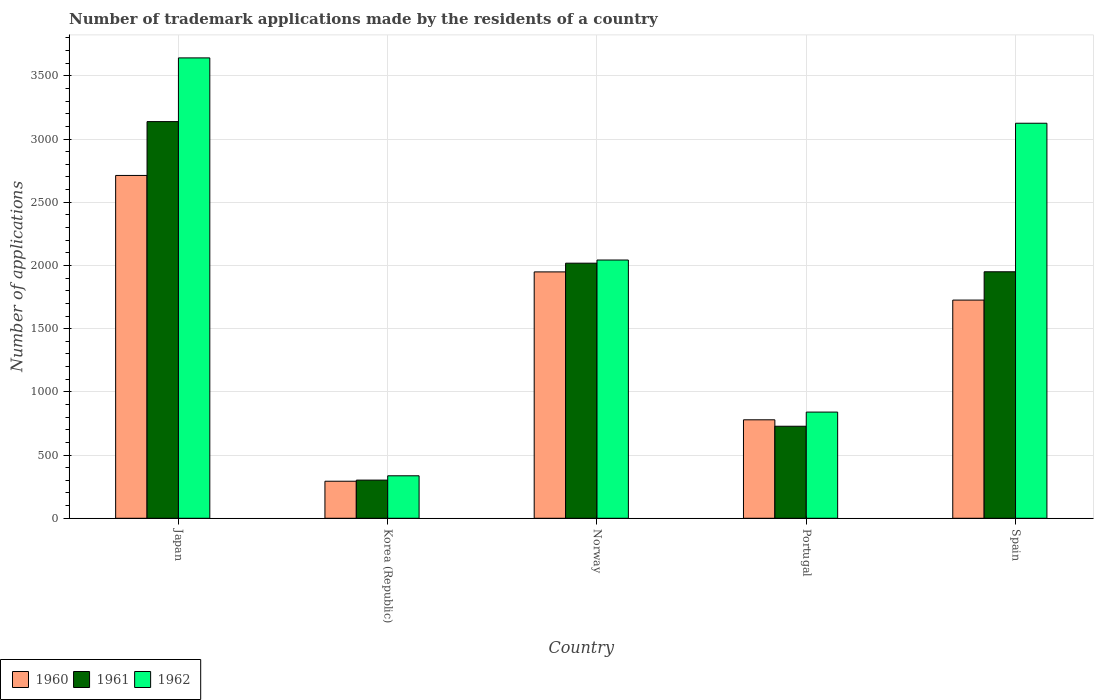How many groups of bars are there?
Your response must be concise. 5. Are the number of bars per tick equal to the number of legend labels?
Offer a very short reply. Yes. How many bars are there on the 4th tick from the left?
Keep it short and to the point. 3. How many bars are there on the 4th tick from the right?
Provide a short and direct response. 3. In how many cases, is the number of bars for a given country not equal to the number of legend labels?
Make the answer very short. 0. What is the number of trademark applications made by the residents in 1960 in Korea (Republic)?
Provide a short and direct response. 293. Across all countries, what is the maximum number of trademark applications made by the residents in 1961?
Keep it short and to the point. 3138. Across all countries, what is the minimum number of trademark applications made by the residents in 1961?
Provide a short and direct response. 302. In which country was the number of trademark applications made by the residents in 1961 maximum?
Ensure brevity in your answer.  Japan. What is the total number of trademark applications made by the residents in 1961 in the graph?
Offer a terse response. 8136. What is the difference between the number of trademark applications made by the residents in 1962 in Norway and that in Spain?
Offer a very short reply. -1082. What is the difference between the number of trademark applications made by the residents in 1961 in Spain and the number of trademark applications made by the residents in 1962 in Norway?
Provide a succinct answer. -93. What is the average number of trademark applications made by the residents in 1961 per country?
Offer a very short reply. 1627.2. What is the difference between the number of trademark applications made by the residents of/in 1960 and number of trademark applications made by the residents of/in 1962 in Spain?
Provide a short and direct response. -1399. What is the ratio of the number of trademark applications made by the residents in 1961 in Norway to that in Portugal?
Your answer should be compact. 2.77. Is the difference between the number of trademark applications made by the residents in 1960 in Korea (Republic) and Spain greater than the difference between the number of trademark applications made by the residents in 1962 in Korea (Republic) and Spain?
Provide a succinct answer. Yes. What is the difference between the highest and the second highest number of trademark applications made by the residents in 1961?
Make the answer very short. 1120. What is the difference between the highest and the lowest number of trademark applications made by the residents in 1961?
Provide a succinct answer. 2836. In how many countries, is the number of trademark applications made by the residents in 1960 greater than the average number of trademark applications made by the residents in 1960 taken over all countries?
Your answer should be compact. 3. Is it the case that in every country, the sum of the number of trademark applications made by the residents in 1960 and number of trademark applications made by the residents in 1961 is greater than the number of trademark applications made by the residents in 1962?
Make the answer very short. Yes. How many bars are there?
Offer a terse response. 15. How many countries are there in the graph?
Provide a short and direct response. 5. What is the difference between two consecutive major ticks on the Y-axis?
Offer a terse response. 500. Does the graph contain grids?
Offer a terse response. Yes. What is the title of the graph?
Provide a succinct answer. Number of trademark applications made by the residents of a country. Does "2010" appear as one of the legend labels in the graph?
Make the answer very short. No. What is the label or title of the Y-axis?
Ensure brevity in your answer.  Number of applications. What is the Number of applications of 1960 in Japan?
Your response must be concise. 2712. What is the Number of applications in 1961 in Japan?
Offer a very short reply. 3138. What is the Number of applications of 1962 in Japan?
Your response must be concise. 3642. What is the Number of applications in 1960 in Korea (Republic)?
Your answer should be very brief. 293. What is the Number of applications of 1961 in Korea (Republic)?
Ensure brevity in your answer.  302. What is the Number of applications in 1962 in Korea (Republic)?
Provide a succinct answer. 336. What is the Number of applications in 1960 in Norway?
Your response must be concise. 1949. What is the Number of applications of 1961 in Norway?
Keep it short and to the point. 2018. What is the Number of applications of 1962 in Norway?
Give a very brief answer. 2043. What is the Number of applications in 1960 in Portugal?
Ensure brevity in your answer.  779. What is the Number of applications in 1961 in Portugal?
Ensure brevity in your answer.  728. What is the Number of applications of 1962 in Portugal?
Your answer should be compact. 840. What is the Number of applications in 1960 in Spain?
Provide a short and direct response. 1726. What is the Number of applications in 1961 in Spain?
Your response must be concise. 1950. What is the Number of applications of 1962 in Spain?
Offer a terse response. 3125. Across all countries, what is the maximum Number of applications in 1960?
Give a very brief answer. 2712. Across all countries, what is the maximum Number of applications of 1961?
Provide a succinct answer. 3138. Across all countries, what is the maximum Number of applications of 1962?
Provide a succinct answer. 3642. Across all countries, what is the minimum Number of applications in 1960?
Your response must be concise. 293. Across all countries, what is the minimum Number of applications in 1961?
Your answer should be compact. 302. Across all countries, what is the minimum Number of applications of 1962?
Your answer should be compact. 336. What is the total Number of applications in 1960 in the graph?
Keep it short and to the point. 7459. What is the total Number of applications in 1961 in the graph?
Give a very brief answer. 8136. What is the total Number of applications in 1962 in the graph?
Provide a short and direct response. 9986. What is the difference between the Number of applications in 1960 in Japan and that in Korea (Republic)?
Provide a succinct answer. 2419. What is the difference between the Number of applications of 1961 in Japan and that in Korea (Republic)?
Your answer should be very brief. 2836. What is the difference between the Number of applications in 1962 in Japan and that in Korea (Republic)?
Your answer should be very brief. 3306. What is the difference between the Number of applications in 1960 in Japan and that in Norway?
Your answer should be very brief. 763. What is the difference between the Number of applications of 1961 in Japan and that in Norway?
Make the answer very short. 1120. What is the difference between the Number of applications in 1962 in Japan and that in Norway?
Give a very brief answer. 1599. What is the difference between the Number of applications in 1960 in Japan and that in Portugal?
Your answer should be very brief. 1933. What is the difference between the Number of applications of 1961 in Japan and that in Portugal?
Your response must be concise. 2410. What is the difference between the Number of applications of 1962 in Japan and that in Portugal?
Give a very brief answer. 2802. What is the difference between the Number of applications in 1960 in Japan and that in Spain?
Provide a short and direct response. 986. What is the difference between the Number of applications of 1961 in Japan and that in Spain?
Your answer should be compact. 1188. What is the difference between the Number of applications in 1962 in Japan and that in Spain?
Offer a very short reply. 517. What is the difference between the Number of applications of 1960 in Korea (Republic) and that in Norway?
Your answer should be very brief. -1656. What is the difference between the Number of applications of 1961 in Korea (Republic) and that in Norway?
Provide a short and direct response. -1716. What is the difference between the Number of applications in 1962 in Korea (Republic) and that in Norway?
Offer a terse response. -1707. What is the difference between the Number of applications of 1960 in Korea (Republic) and that in Portugal?
Your answer should be compact. -486. What is the difference between the Number of applications of 1961 in Korea (Republic) and that in Portugal?
Give a very brief answer. -426. What is the difference between the Number of applications in 1962 in Korea (Republic) and that in Portugal?
Ensure brevity in your answer.  -504. What is the difference between the Number of applications in 1960 in Korea (Republic) and that in Spain?
Give a very brief answer. -1433. What is the difference between the Number of applications of 1961 in Korea (Republic) and that in Spain?
Your response must be concise. -1648. What is the difference between the Number of applications of 1962 in Korea (Republic) and that in Spain?
Ensure brevity in your answer.  -2789. What is the difference between the Number of applications in 1960 in Norway and that in Portugal?
Your answer should be very brief. 1170. What is the difference between the Number of applications in 1961 in Norway and that in Portugal?
Give a very brief answer. 1290. What is the difference between the Number of applications in 1962 in Norway and that in Portugal?
Give a very brief answer. 1203. What is the difference between the Number of applications in 1960 in Norway and that in Spain?
Your response must be concise. 223. What is the difference between the Number of applications in 1962 in Norway and that in Spain?
Your answer should be compact. -1082. What is the difference between the Number of applications of 1960 in Portugal and that in Spain?
Keep it short and to the point. -947. What is the difference between the Number of applications of 1961 in Portugal and that in Spain?
Provide a succinct answer. -1222. What is the difference between the Number of applications of 1962 in Portugal and that in Spain?
Your answer should be very brief. -2285. What is the difference between the Number of applications in 1960 in Japan and the Number of applications in 1961 in Korea (Republic)?
Offer a terse response. 2410. What is the difference between the Number of applications in 1960 in Japan and the Number of applications in 1962 in Korea (Republic)?
Ensure brevity in your answer.  2376. What is the difference between the Number of applications of 1961 in Japan and the Number of applications of 1962 in Korea (Republic)?
Offer a very short reply. 2802. What is the difference between the Number of applications of 1960 in Japan and the Number of applications of 1961 in Norway?
Offer a terse response. 694. What is the difference between the Number of applications in 1960 in Japan and the Number of applications in 1962 in Norway?
Give a very brief answer. 669. What is the difference between the Number of applications in 1961 in Japan and the Number of applications in 1962 in Norway?
Keep it short and to the point. 1095. What is the difference between the Number of applications in 1960 in Japan and the Number of applications in 1961 in Portugal?
Your answer should be compact. 1984. What is the difference between the Number of applications in 1960 in Japan and the Number of applications in 1962 in Portugal?
Offer a very short reply. 1872. What is the difference between the Number of applications in 1961 in Japan and the Number of applications in 1962 in Portugal?
Your response must be concise. 2298. What is the difference between the Number of applications of 1960 in Japan and the Number of applications of 1961 in Spain?
Offer a very short reply. 762. What is the difference between the Number of applications in 1960 in Japan and the Number of applications in 1962 in Spain?
Offer a very short reply. -413. What is the difference between the Number of applications of 1961 in Japan and the Number of applications of 1962 in Spain?
Keep it short and to the point. 13. What is the difference between the Number of applications in 1960 in Korea (Republic) and the Number of applications in 1961 in Norway?
Provide a short and direct response. -1725. What is the difference between the Number of applications of 1960 in Korea (Republic) and the Number of applications of 1962 in Norway?
Offer a terse response. -1750. What is the difference between the Number of applications in 1961 in Korea (Republic) and the Number of applications in 1962 in Norway?
Your answer should be compact. -1741. What is the difference between the Number of applications in 1960 in Korea (Republic) and the Number of applications in 1961 in Portugal?
Keep it short and to the point. -435. What is the difference between the Number of applications of 1960 in Korea (Republic) and the Number of applications of 1962 in Portugal?
Give a very brief answer. -547. What is the difference between the Number of applications in 1961 in Korea (Republic) and the Number of applications in 1962 in Portugal?
Ensure brevity in your answer.  -538. What is the difference between the Number of applications of 1960 in Korea (Republic) and the Number of applications of 1961 in Spain?
Ensure brevity in your answer.  -1657. What is the difference between the Number of applications of 1960 in Korea (Republic) and the Number of applications of 1962 in Spain?
Provide a succinct answer. -2832. What is the difference between the Number of applications of 1961 in Korea (Republic) and the Number of applications of 1962 in Spain?
Offer a very short reply. -2823. What is the difference between the Number of applications in 1960 in Norway and the Number of applications in 1961 in Portugal?
Your response must be concise. 1221. What is the difference between the Number of applications of 1960 in Norway and the Number of applications of 1962 in Portugal?
Your response must be concise. 1109. What is the difference between the Number of applications of 1961 in Norway and the Number of applications of 1962 in Portugal?
Offer a very short reply. 1178. What is the difference between the Number of applications in 1960 in Norway and the Number of applications in 1961 in Spain?
Your answer should be very brief. -1. What is the difference between the Number of applications of 1960 in Norway and the Number of applications of 1962 in Spain?
Offer a terse response. -1176. What is the difference between the Number of applications of 1961 in Norway and the Number of applications of 1962 in Spain?
Your answer should be compact. -1107. What is the difference between the Number of applications in 1960 in Portugal and the Number of applications in 1961 in Spain?
Provide a short and direct response. -1171. What is the difference between the Number of applications in 1960 in Portugal and the Number of applications in 1962 in Spain?
Keep it short and to the point. -2346. What is the difference between the Number of applications in 1961 in Portugal and the Number of applications in 1962 in Spain?
Ensure brevity in your answer.  -2397. What is the average Number of applications in 1960 per country?
Make the answer very short. 1491.8. What is the average Number of applications in 1961 per country?
Provide a succinct answer. 1627.2. What is the average Number of applications in 1962 per country?
Offer a terse response. 1997.2. What is the difference between the Number of applications of 1960 and Number of applications of 1961 in Japan?
Give a very brief answer. -426. What is the difference between the Number of applications in 1960 and Number of applications in 1962 in Japan?
Provide a short and direct response. -930. What is the difference between the Number of applications of 1961 and Number of applications of 1962 in Japan?
Your response must be concise. -504. What is the difference between the Number of applications in 1960 and Number of applications in 1961 in Korea (Republic)?
Offer a terse response. -9. What is the difference between the Number of applications in 1960 and Number of applications in 1962 in Korea (Republic)?
Provide a short and direct response. -43. What is the difference between the Number of applications in 1961 and Number of applications in 1962 in Korea (Republic)?
Offer a terse response. -34. What is the difference between the Number of applications in 1960 and Number of applications in 1961 in Norway?
Your answer should be very brief. -69. What is the difference between the Number of applications of 1960 and Number of applications of 1962 in Norway?
Make the answer very short. -94. What is the difference between the Number of applications in 1960 and Number of applications in 1961 in Portugal?
Offer a very short reply. 51. What is the difference between the Number of applications of 1960 and Number of applications of 1962 in Portugal?
Provide a succinct answer. -61. What is the difference between the Number of applications of 1961 and Number of applications of 1962 in Portugal?
Your answer should be very brief. -112. What is the difference between the Number of applications of 1960 and Number of applications of 1961 in Spain?
Provide a short and direct response. -224. What is the difference between the Number of applications of 1960 and Number of applications of 1962 in Spain?
Keep it short and to the point. -1399. What is the difference between the Number of applications of 1961 and Number of applications of 1962 in Spain?
Offer a very short reply. -1175. What is the ratio of the Number of applications in 1960 in Japan to that in Korea (Republic)?
Offer a very short reply. 9.26. What is the ratio of the Number of applications of 1961 in Japan to that in Korea (Republic)?
Provide a short and direct response. 10.39. What is the ratio of the Number of applications of 1962 in Japan to that in Korea (Republic)?
Provide a succinct answer. 10.84. What is the ratio of the Number of applications in 1960 in Japan to that in Norway?
Provide a succinct answer. 1.39. What is the ratio of the Number of applications of 1961 in Japan to that in Norway?
Give a very brief answer. 1.55. What is the ratio of the Number of applications in 1962 in Japan to that in Norway?
Provide a short and direct response. 1.78. What is the ratio of the Number of applications of 1960 in Japan to that in Portugal?
Your answer should be compact. 3.48. What is the ratio of the Number of applications in 1961 in Japan to that in Portugal?
Provide a short and direct response. 4.31. What is the ratio of the Number of applications in 1962 in Japan to that in Portugal?
Offer a terse response. 4.34. What is the ratio of the Number of applications of 1960 in Japan to that in Spain?
Offer a terse response. 1.57. What is the ratio of the Number of applications of 1961 in Japan to that in Spain?
Offer a very short reply. 1.61. What is the ratio of the Number of applications in 1962 in Japan to that in Spain?
Your answer should be very brief. 1.17. What is the ratio of the Number of applications in 1960 in Korea (Republic) to that in Norway?
Give a very brief answer. 0.15. What is the ratio of the Number of applications of 1961 in Korea (Republic) to that in Norway?
Your answer should be very brief. 0.15. What is the ratio of the Number of applications of 1962 in Korea (Republic) to that in Norway?
Keep it short and to the point. 0.16. What is the ratio of the Number of applications in 1960 in Korea (Republic) to that in Portugal?
Give a very brief answer. 0.38. What is the ratio of the Number of applications of 1961 in Korea (Republic) to that in Portugal?
Ensure brevity in your answer.  0.41. What is the ratio of the Number of applications in 1960 in Korea (Republic) to that in Spain?
Your response must be concise. 0.17. What is the ratio of the Number of applications in 1961 in Korea (Republic) to that in Spain?
Your answer should be very brief. 0.15. What is the ratio of the Number of applications of 1962 in Korea (Republic) to that in Spain?
Provide a succinct answer. 0.11. What is the ratio of the Number of applications of 1960 in Norway to that in Portugal?
Your response must be concise. 2.5. What is the ratio of the Number of applications in 1961 in Norway to that in Portugal?
Provide a short and direct response. 2.77. What is the ratio of the Number of applications of 1962 in Norway to that in Portugal?
Ensure brevity in your answer.  2.43. What is the ratio of the Number of applications in 1960 in Norway to that in Spain?
Your answer should be compact. 1.13. What is the ratio of the Number of applications in 1961 in Norway to that in Spain?
Your response must be concise. 1.03. What is the ratio of the Number of applications in 1962 in Norway to that in Spain?
Ensure brevity in your answer.  0.65. What is the ratio of the Number of applications in 1960 in Portugal to that in Spain?
Offer a very short reply. 0.45. What is the ratio of the Number of applications of 1961 in Portugal to that in Spain?
Ensure brevity in your answer.  0.37. What is the ratio of the Number of applications in 1962 in Portugal to that in Spain?
Ensure brevity in your answer.  0.27. What is the difference between the highest and the second highest Number of applications of 1960?
Provide a short and direct response. 763. What is the difference between the highest and the second highest Number of applications in 1961?
Your answer should be compact. 1120. What is the difference between the highest and the second highest Number of applications in 1962?
Provide a succinct answer. 517. What is the difference between the highest and the lowest Number of applications of 1960?
Give a very brief answer. 2419. What is the difference between the highest and the lowest Number of applications in 1961?
Your answer should be compact. 2836. What is the difference between the highest and the lowest Number of applications of 1962?
Provide a short and direct response. 3306. 